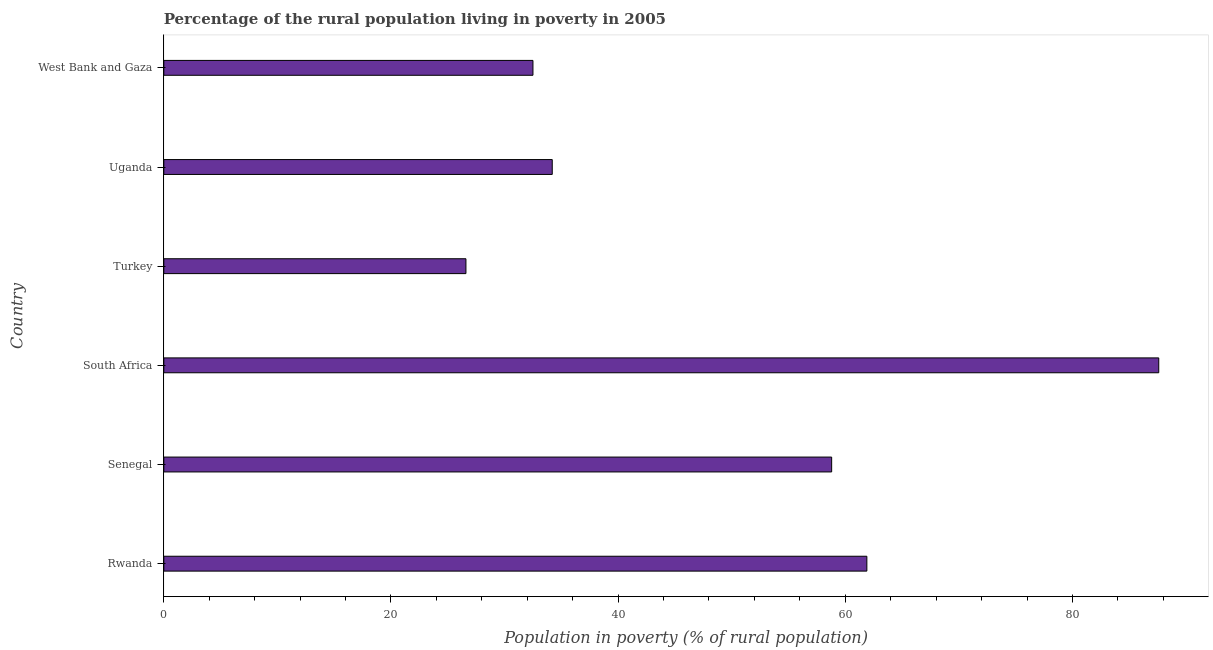Does the graph contain any zero values?
Your response must be concise. No. Does the graph contain grids?
Ensure brevity in your answer.  No. What is the title of the graph?
Your response must be concise. Percentage of the rural population living in poverty in 2005. What is the label or title of the X-axis?
Offer a terse response. Population in poverty (% of rural population). What is the percentage of rural population living below poverty line in Uganda?
Give a very brief answer. 34.2. Across all countries, what is the maximum percentage of rural population living below poverty line?
Provide a succinct answer. 87.6. Across all countries, what is the minimum percentage of rural population living below poverty line?
Ensure brevity in your answer.  26.6. In which country was the percentage of rural population living below poverty line maximum?
Your response must be concise. South Africa. What is the sum of the percentage of rural population living below poverty line?
Ensure brevity in your answer.  301.6. What is the difference between the percentage of rural population living below poverty line in Rwanda and West Bank and Gaza?
Give a very brief answer. 29.4. What is the average percentage of rural population living below poverty line per country?
Keep it short and to the point. 50.27. What is the median percentage of rural population living below poverty line?
Make the answer very short. 46.5. What is the ratio of the percentage of rural population living below poverty line in Rwanda to that in South Africa?
Offer a terse response. 0.71. Is the percentage of rural population living below poverty line in Turkey less than that in West Bank and Gaza?
Your answer should be very brief. Yes. Is the difference between the percentage of rural population living below poverty line in Turkey and West Bank and Gaza greater than the difference between any two countries?
Give a very brief answer. No. What is the difference between the highest and the second highest percentage of rural population living below poverty line?
Give a very brief answer. 25.7. What is the difference between the highest and the lowest percentage of rural population living below poverty line?
Provide a succinct answer. 61. Are all the bars in the graph horizontal?
Keep it short and to the point. Yes. What is the difference between two consecutive major ticks on the X-axis?
Your answer should be very brief. 20. What is the Population in poverty (% of rural population) in Rwanda?
Offer a very short reply. 61.9. What is the Population in poverty (% of rural population) of Senegal?
Your response must be concise. 58.8. What is the Population in poverty (% of rural population) in South Africa?
Make the answer very short. 87.6. What is the Population in poverty (% of rural population) in Turkey?
Provide a short and direct response. 26.6. What is the Population in poverty (% of rural population) of Uganda?
Offer a terse response. 34.2. What is the Population in poverty (% of rural population) in West Bank and Gaza?
Your answer should be very brief. 32.5. What is the difference between the Population in poverty (% of rural population) in Rwanda and South Africa?
Keep it short and to the point. -25.7. What is the difference between the Population in poverty (% of rural population) in Rwanda and Turkey?
Offer a very short reply. 35.3. What is the difference between the Population in poverty (% of rural population) in Rwanda and Uganda?
Your answer should be compact. 27.7. What is the difference between the Population in poverty (% of rural population) in Rwanda and West Bank and Gaza?
Provide a succinct answer. 29.4. What is the difference between the Population in poverty (% of rural population) in Senegal and South Africa?
Your answer should be very brief. -28.8. What is the difference between the Population in poverty (% of rural population) in Senegal and Turkey?
Your answer should be very brief. 32.2. What is the difference between the Population in poverty (% of rural population) in Senegal and Uganda?
Your answer should be compact. 24.6. What is the difference between the Population in poverty (% of rural population) in Senegal and West Bank and Gaza?
Your answer should be compact. 26.3. What is the difference between the Population in poverty (% of rural population) in South Africa and Turkey?
Your answer should be very brief. 61. What is the difference between the Population in poverty (% of rural population) in South Africa and Uganda?
Provide a short and direct response. 53.4. What is the difference between the Population in poverty (% of rural population) in South Africa and West Bank and Gaza?
Your answer should be very brief. 55.1. What is the difference between the Population in poverty (% of rural population) in Turkey and Uganda?
Ensure brevity in your answer.  -7.6. What is the ratio of the Population in poverty (% of rural population) in Rwanda to that in Senegal?
Ensure brevity in your answer.  1.05. What is the ratio of the Population in poverty (% of rural population) in Rwanda to that in South Africa?
Your answer should be compact. 0.71. What is the ratio of the Population in poverty (% of rural population) in Rwanda to that in Turkey?
Keep it short and to the point. 2.33. What is the ratio of the Population in poverty (% of rural population) in Rwanda to that in Uganda?
Provide a short and direct response. 1.81. What is the ratio of the Population in poverty (% of rural population) in Rwanda to that in West Bank and Gaza?
Offer a terse response. 1.91. What is the ratio of the Population in poverty (% of rural population) in Senegal to that in South Africa?
Provide a short and direct response. 0.67. What is the ratio of the Population in poverty (% of rural population) in Senegal to that in Turkey?
Offer a very short reply. 2.21. What is the ratio of the Population in poverty (% of rural population) in Senegal to that in Uganda?
Give a very brief answer. 1.72. What is the ratio of the Population in poverty (% of rural population) in Senegal to that in West Bank and Gaza?
Make the answer very short. 1.81. What is the ratio of the Population in poverty (% of rural population) in South Africa to that in Turkey?
Offer a terse response. 3.29. What is the ratio of the Population in poverty (% of rural population) in South Africa to that in Uganda?
Make the answer very short. 2.56. What is the ratio of the Population in poverty (% of rural population) in South Africa to that in West Bank and Gaza?
Give a very brief answer. 2.69. What is the ratio of the Population in poverty (% of rural population) in Turkey to that in Uganda?
Make the answer very short. 0.78. What is the ratio of the Population in poverty (% of rural population) in Turkey to that in West Bank and Gaza?
Offer a terse response. 0.82. What is the ratio of the Population in poverty (% of rural population) in Uganda to that in West Bank and Gaza?
Offer a very short reply. 1.05. 